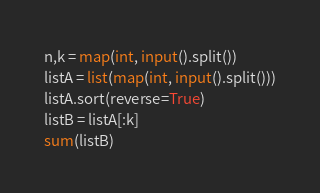<code> <loc_0><loc_0><loc_500><loc_500><_Python_>n,k = map(int, input().split())
listA = list(map(int, input().split()))
listA.sort(reverse=True)
listB = listA[:k]
sum(listB)
</code> 